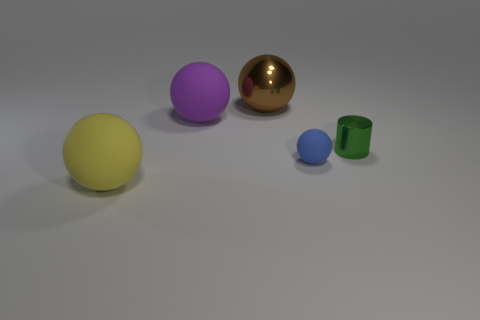What material is the purple object that is the same shape as the big yellow object?
Ensure brevity in your answer.  Rubber. Does the blue object have the same shape as the big yellow rubber thing?
Provide a succinct answer. Yes. What number of small shiny things are on the right side of the small blue thing?
Give a very brief answer. 1. What is the shape of the metal thing that is in front of the metallic object that is to the left of the blue object?
Provide a succinct answer. Cylinder. There is a tiny green thing that is made of the same material as the large brown sphere; what shape is it?
Offer a terse response. Cylinder. There is a rubber ball that is in front of the tiny blue matte sphere; does it have the same size as the thing on the right side of the small blue object?
Offer a very short reply. No. There is a metallic thing that is to the right of the brown sphere; what shape is it?
Keep it short and to the point. Cylinder. What color is the small rubber ball?
Make the answer very short. Blue. There is a brown object; is its size the same as the matte sphere left of the large purple thing?
Ensure brevity in your answer.  Yes. How many rubber objects are small purple blocks or large brown objects?
Offer a very short reply. 0. 